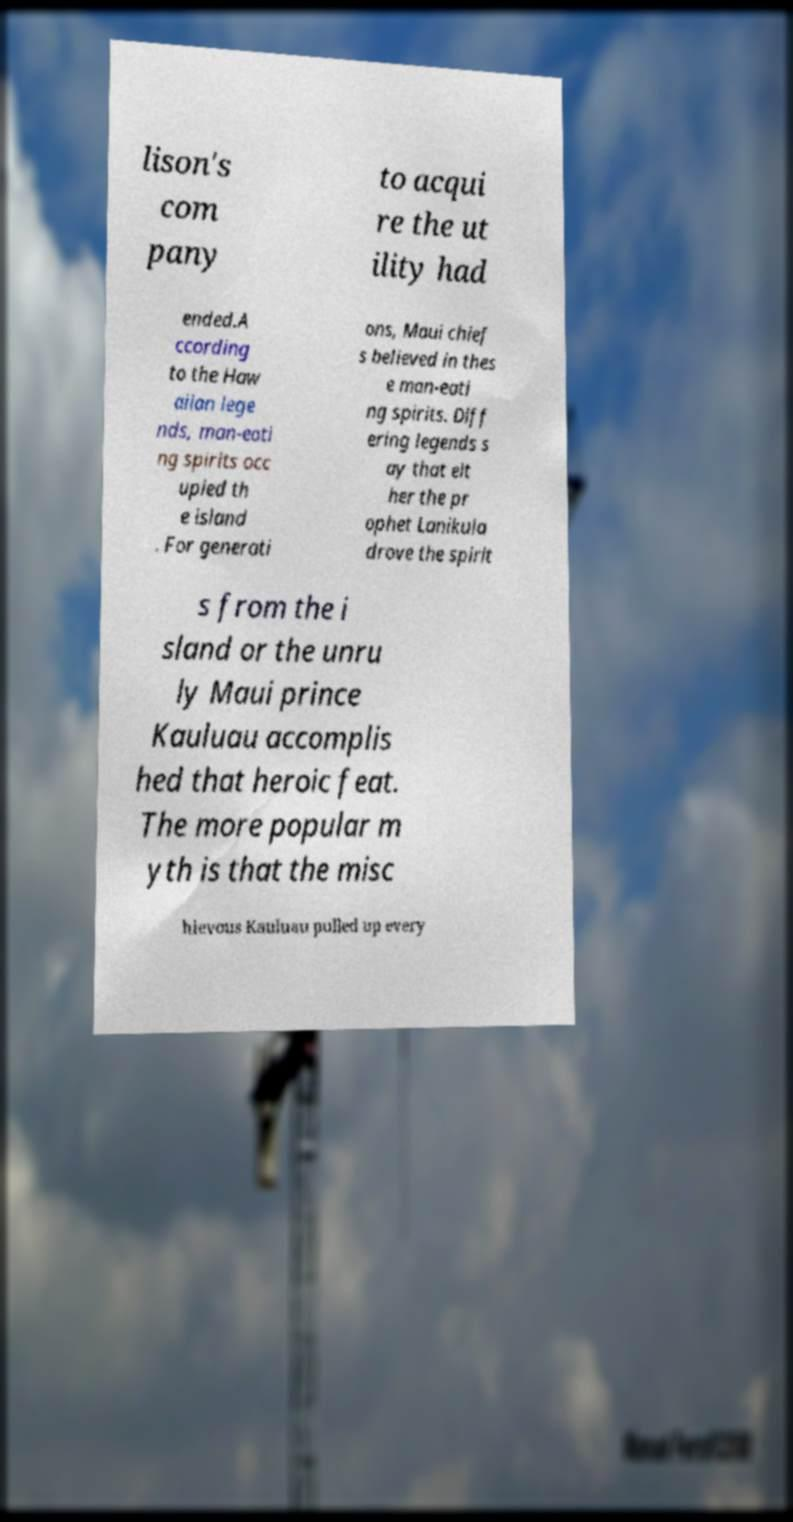Can you read and provide the text displayed in the image?This photo seems to have some interesting text. Can you extract and type it out for me? lison's com pany to acqui re the ut ility had ended.A ccording to the Haw aiian lege nds, man-eati ng spirits occ upied th e island . For generati ons, Maui chief s believed in thes e man-eati ng spirits. Diff ering legends s ay that eit her the pr ophet Lanikula drove the spirit s from the i sland or the unru ly Maui prince Kauluau accomplis hed that heroic feat. The more popular m yth is that the misc hievous Kauluau pulled up every 